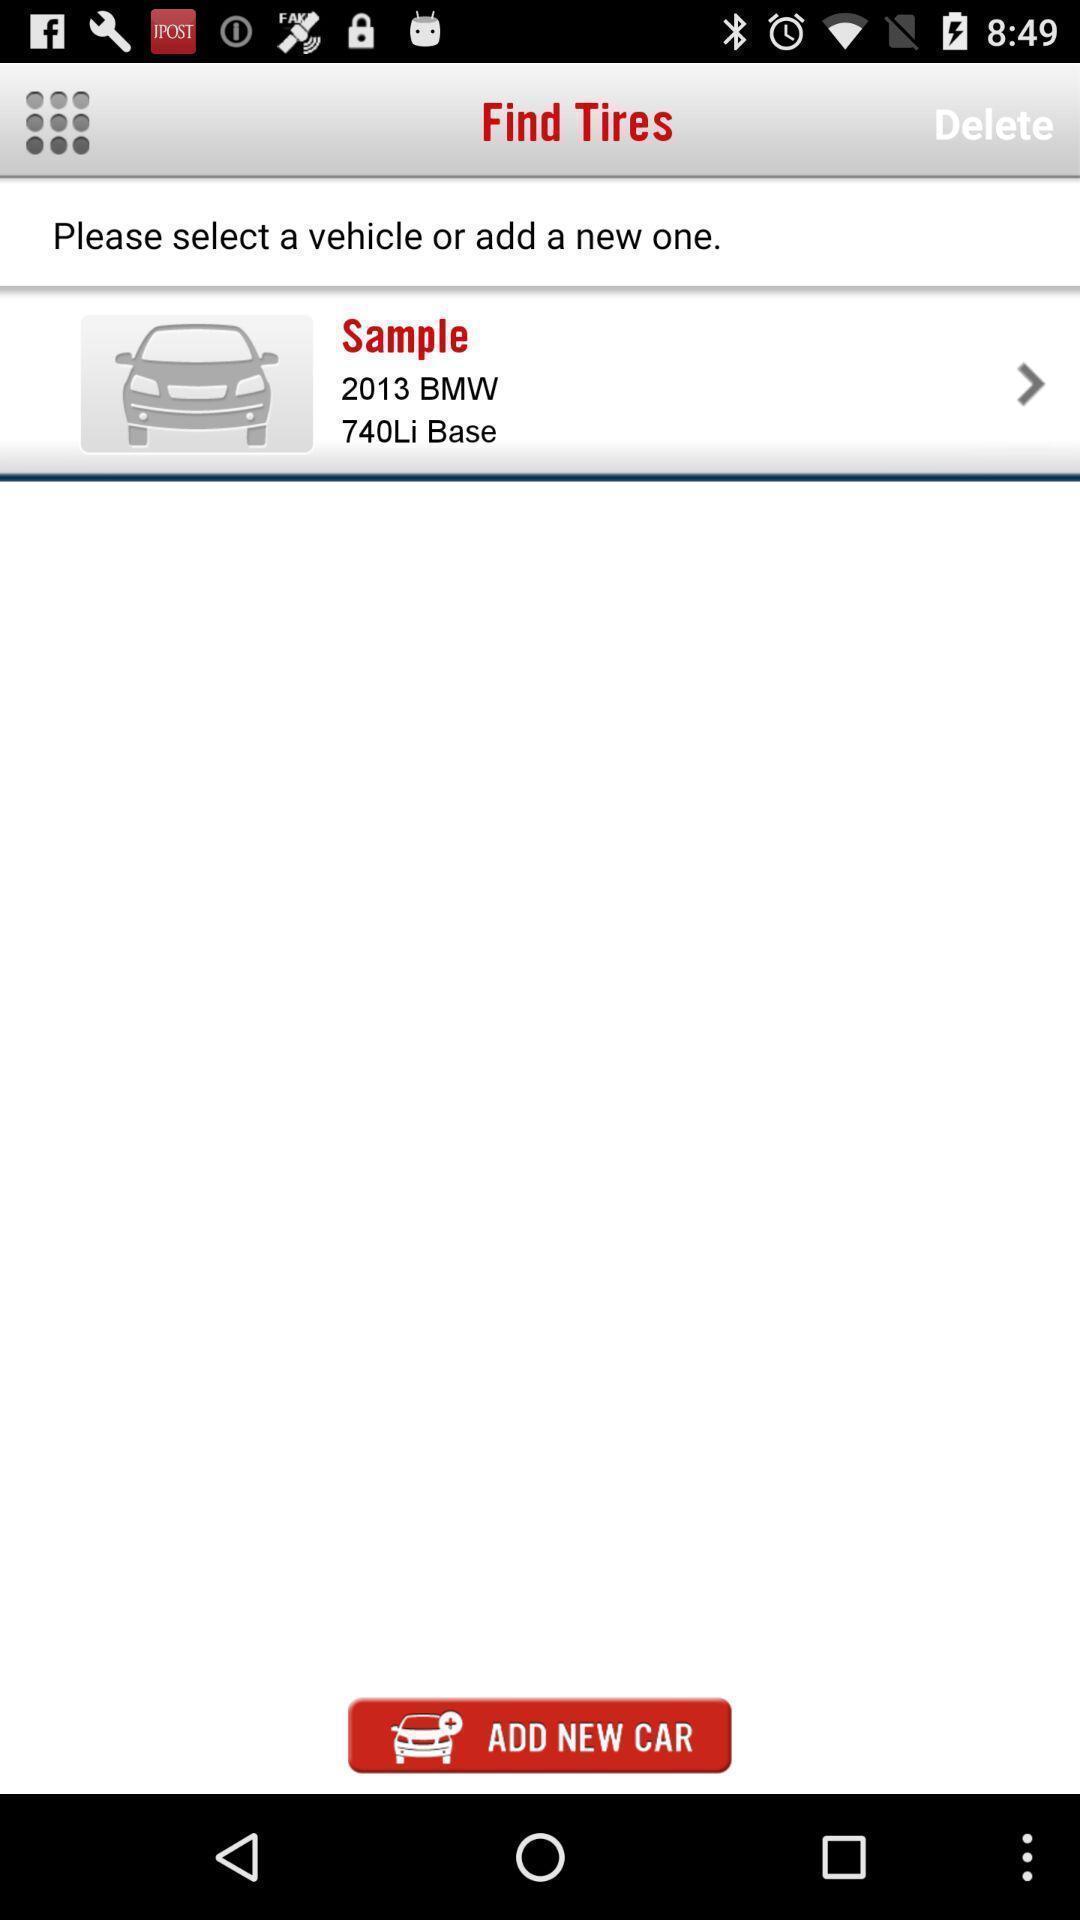Explain the elements present in this screenshot. Screen displaying the page of vehicle maintenance app. 